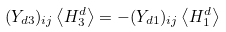Convert formula to latex. <formula><loc_0><loc_0><loc_500><loc_500>( Y _ { d 3 } ) _ { i j } \left < H ^ { d } _ { 3 } \right > = - ( Y _ { d 1 } ) _ { i j } \left < H ^ { d } _ { 1 } \right ></formula> 